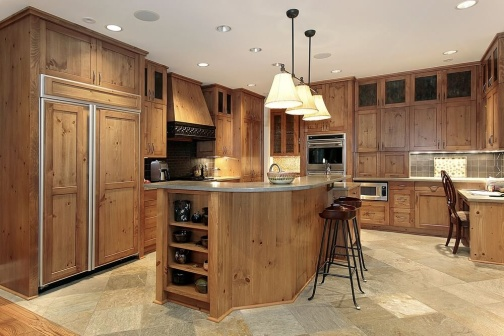What is this photo about? The photo showcases a beautifully designed kitchen whose heart lies in its rustic wooden cabinetry and a center island, which serves multiple functions including a sink and a handy wine rack. The contrasting modern stainless steel appliances blend smoothly into this warm, earth-toned space. The layout, highlighted by a centrally placed island with bar stools, suggests a perfect area for social interactions while cooking or enjoying a casual meal. Lighting fixtures provide both illumination and decorative touches, enhancing the kitchen's welcoming atmosphere. The view through the window above the sink might offer inspiring scenes for anyone engaging in kitchen tasks, positioning this kitchen not just as a place for meal preparation but as the central gathering point of the home. 